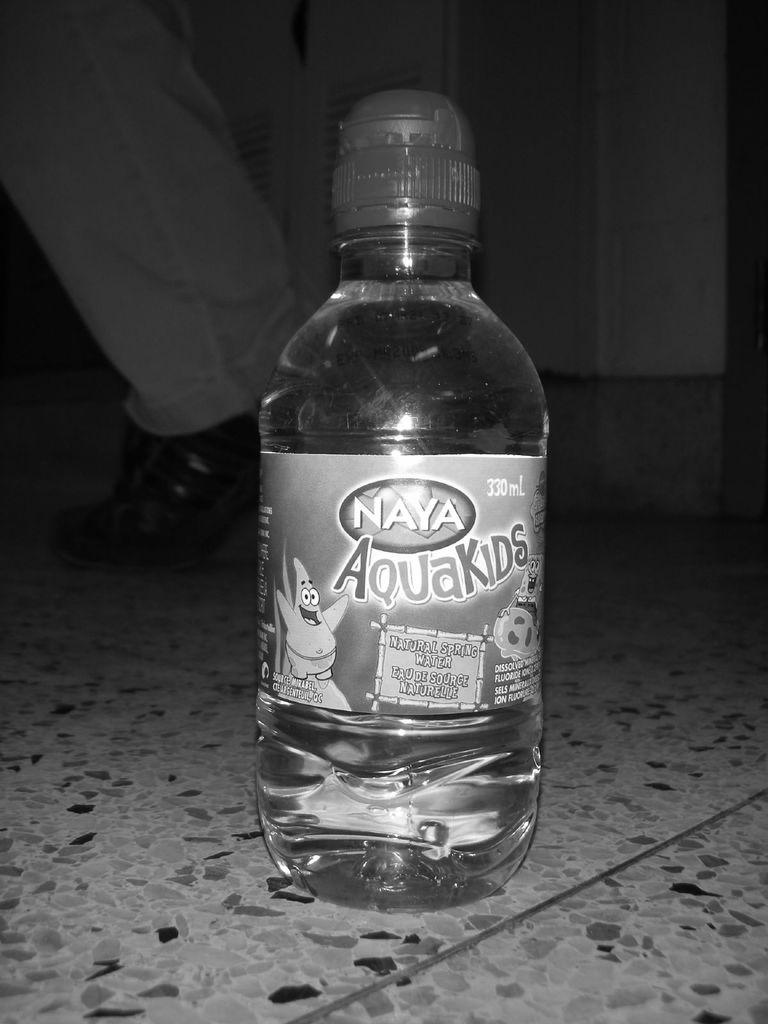<image>
Share a concise interpretation of the image provided. A bottle of Naya Aquakids water with Spongebob and Patrick on the label. 